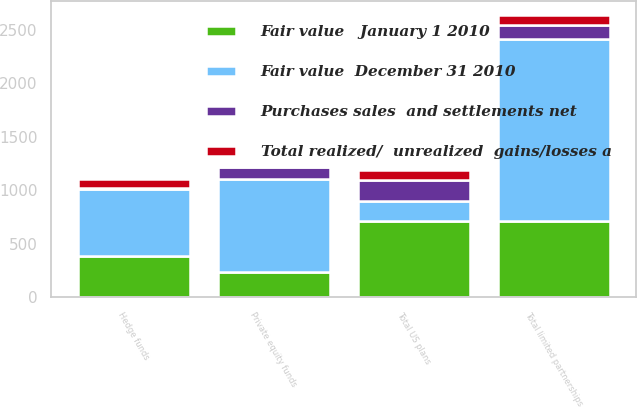Convert chart. <chart><loc_0><loc_0><loc_500><loc_500><stacked_bar_chart><ecel><fcel>Hedge funds<fcel>Private equity funds<fcel>Total limited partnerships<fcel>Total US plans<nl><fcel>Fair value  December 31 2010<fcel>627<fcel>874<fcel>1697<fcel>191<nl><fcel>Purchases sales  and settlements net<fcel>8<fcel>111<fcel>138<fcel>191<nl><fcel>Fair value   January 1 2010<fcel>388<fcel>235<fcel>712<fcel>712<nl><fcel>Total realized/  unrealized  gains/losses a<fcel>79<fcel>12<fcel>91<fcel>92<nl></chart> 